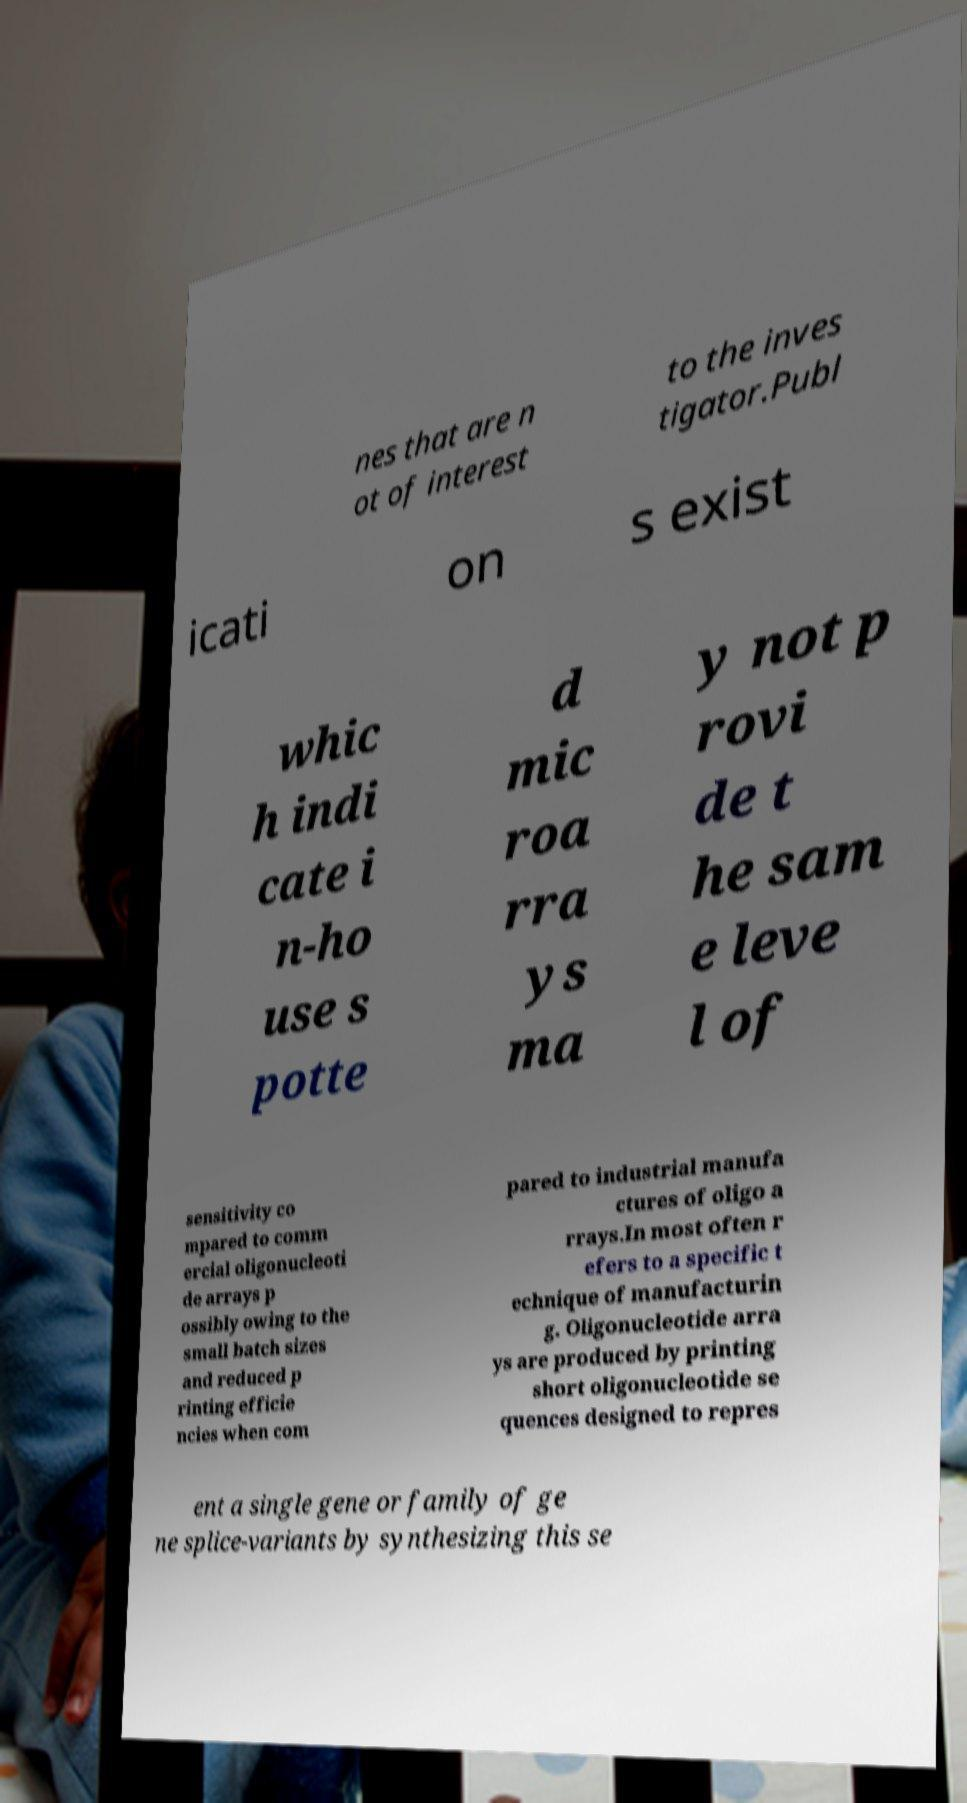Can you accurately transcribe the text from the provided image for me? nes that are n ot of interest to the inves tigator.Publ icati on s exist whic h indi cate i n-ho use s potte d mic roa rra ys ma y not p rovi de t he sam e leve l of sensitivity co mpared to comm ercial oligonucleoti de arrays p ossibly owing to the small batch sizes and reduced p rinting efficie ncies when com pared to industrial manufa ctures of oligo a rrays.In most often r efers to a specific t echnique of manufacturin g. Oligonucleotide arra ys are produced by printing short oligonucleotide se quences designed to repres ent a single gene or family of ge ne splice-variants by synthesizing this se 